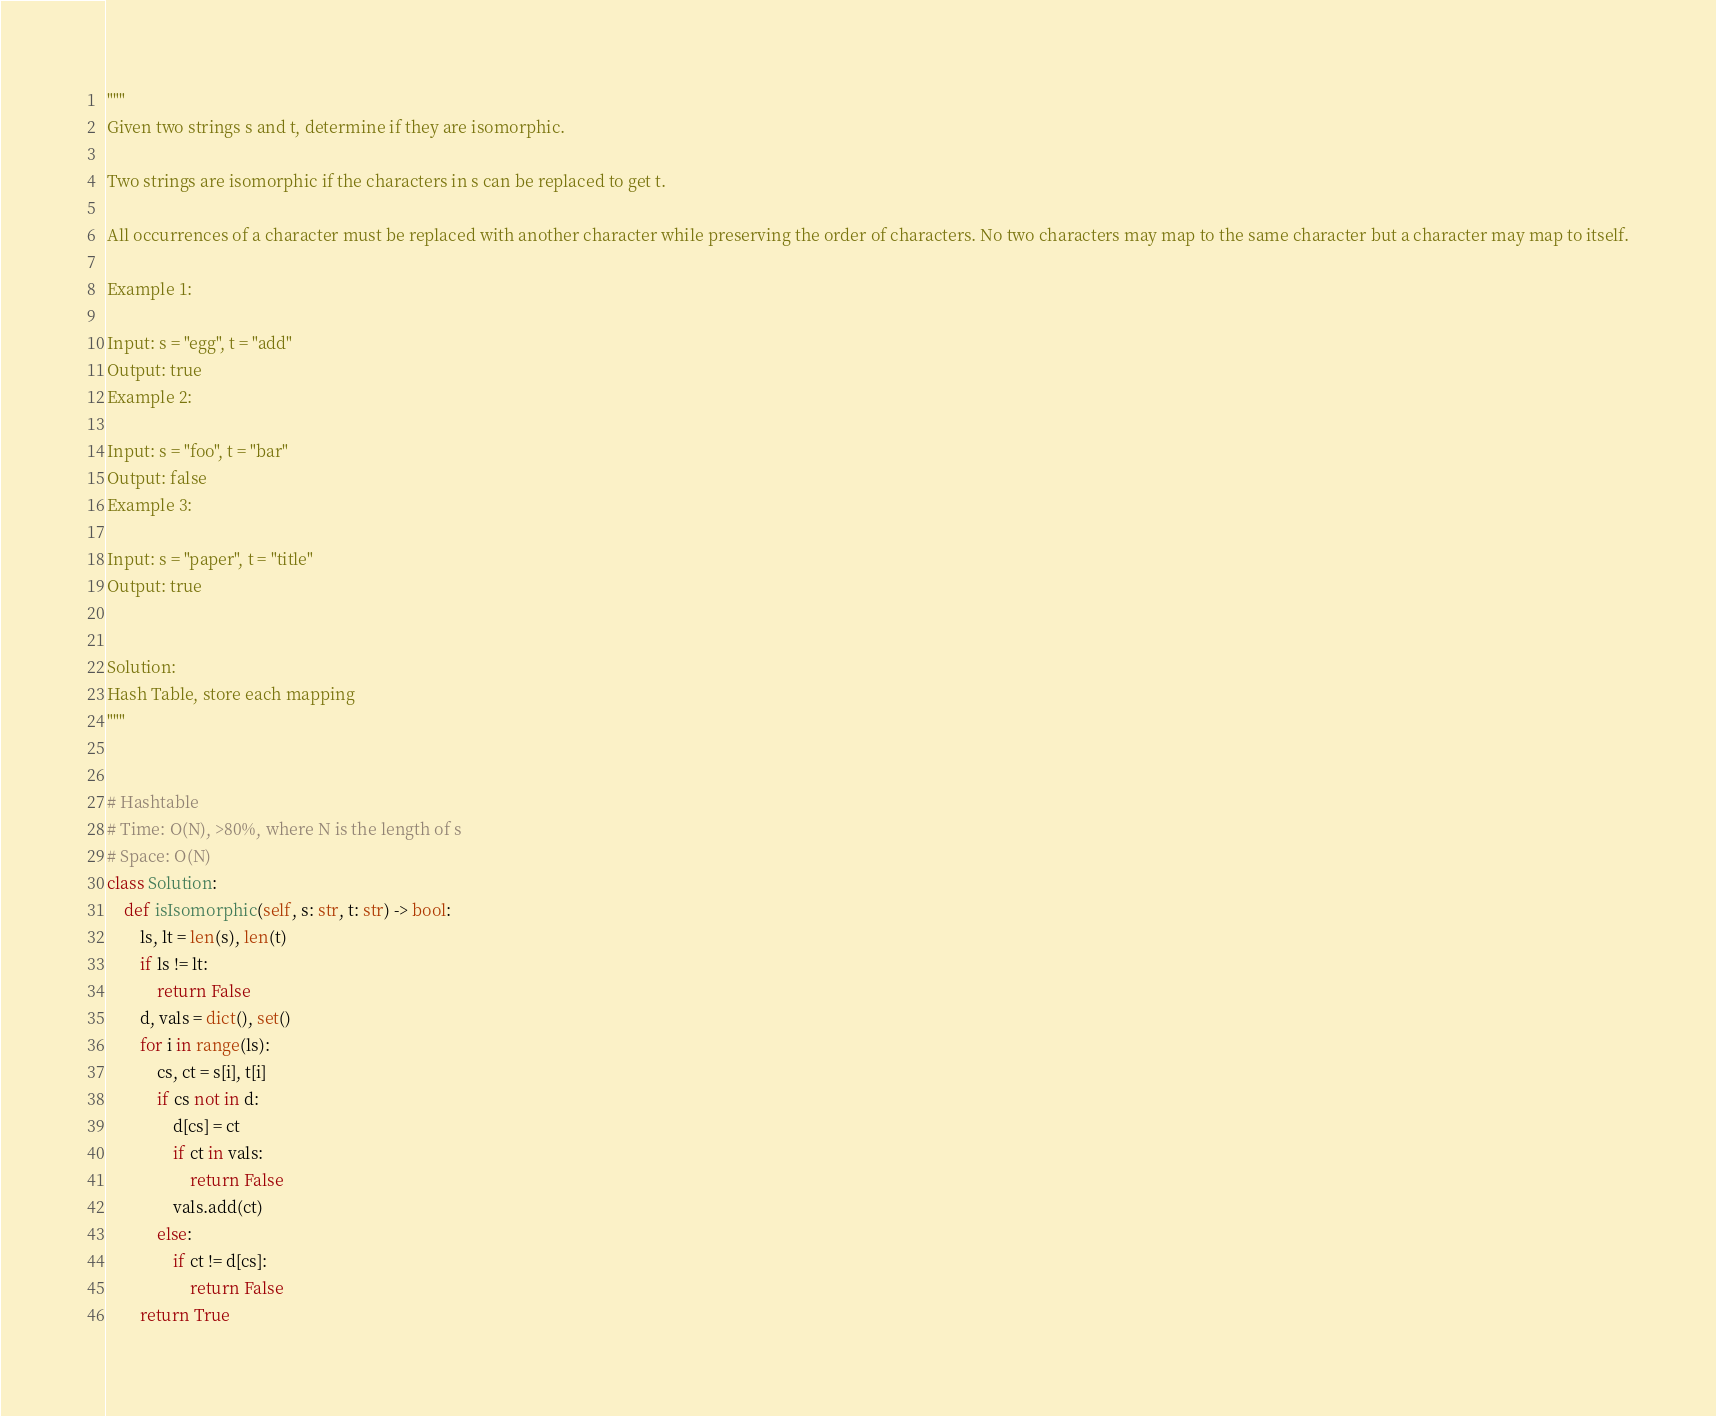Convert code to text. <code><loc_0><loc_0><loc_500><loc_500><_Python_>"""
Given two strings s and t, determine if they are isomorphic.

Two strings are isomorphic if the characters in s can be replaced to get t.

All occurrences of a character must be replaced with another character while preserving the order of characters. No two characters may map to the same character but a character may map to itself.

Example 1:

Input: s = "egg", t = "add"
Output: true
Example 2:

Input: s = "foo", t = "bar"
Output: false
Example 3:

Input: s = "paper", t = "title"
Output: true


Solution:
Hash Table, store each mapping
"""


# Hashtable
# Time: O(N), >80%, where N is the length of s
# Space: O(N)
class Solution:
    def isIsomorphic(self, s: str, t: str) -> bool:
        ls, lt = len(s), len(t)
        if ls != lt:
            return False
        d, vals = dict(), set()
        for i in range(ls):
            cs, ct = s[i], t[i]
            if cs not in d:
                d[cs] = ct
                if ct in vals:
                    return False
                vals.add(ct)
            else:
                if ct != d[cs]:
                    return False
        return True</code> 